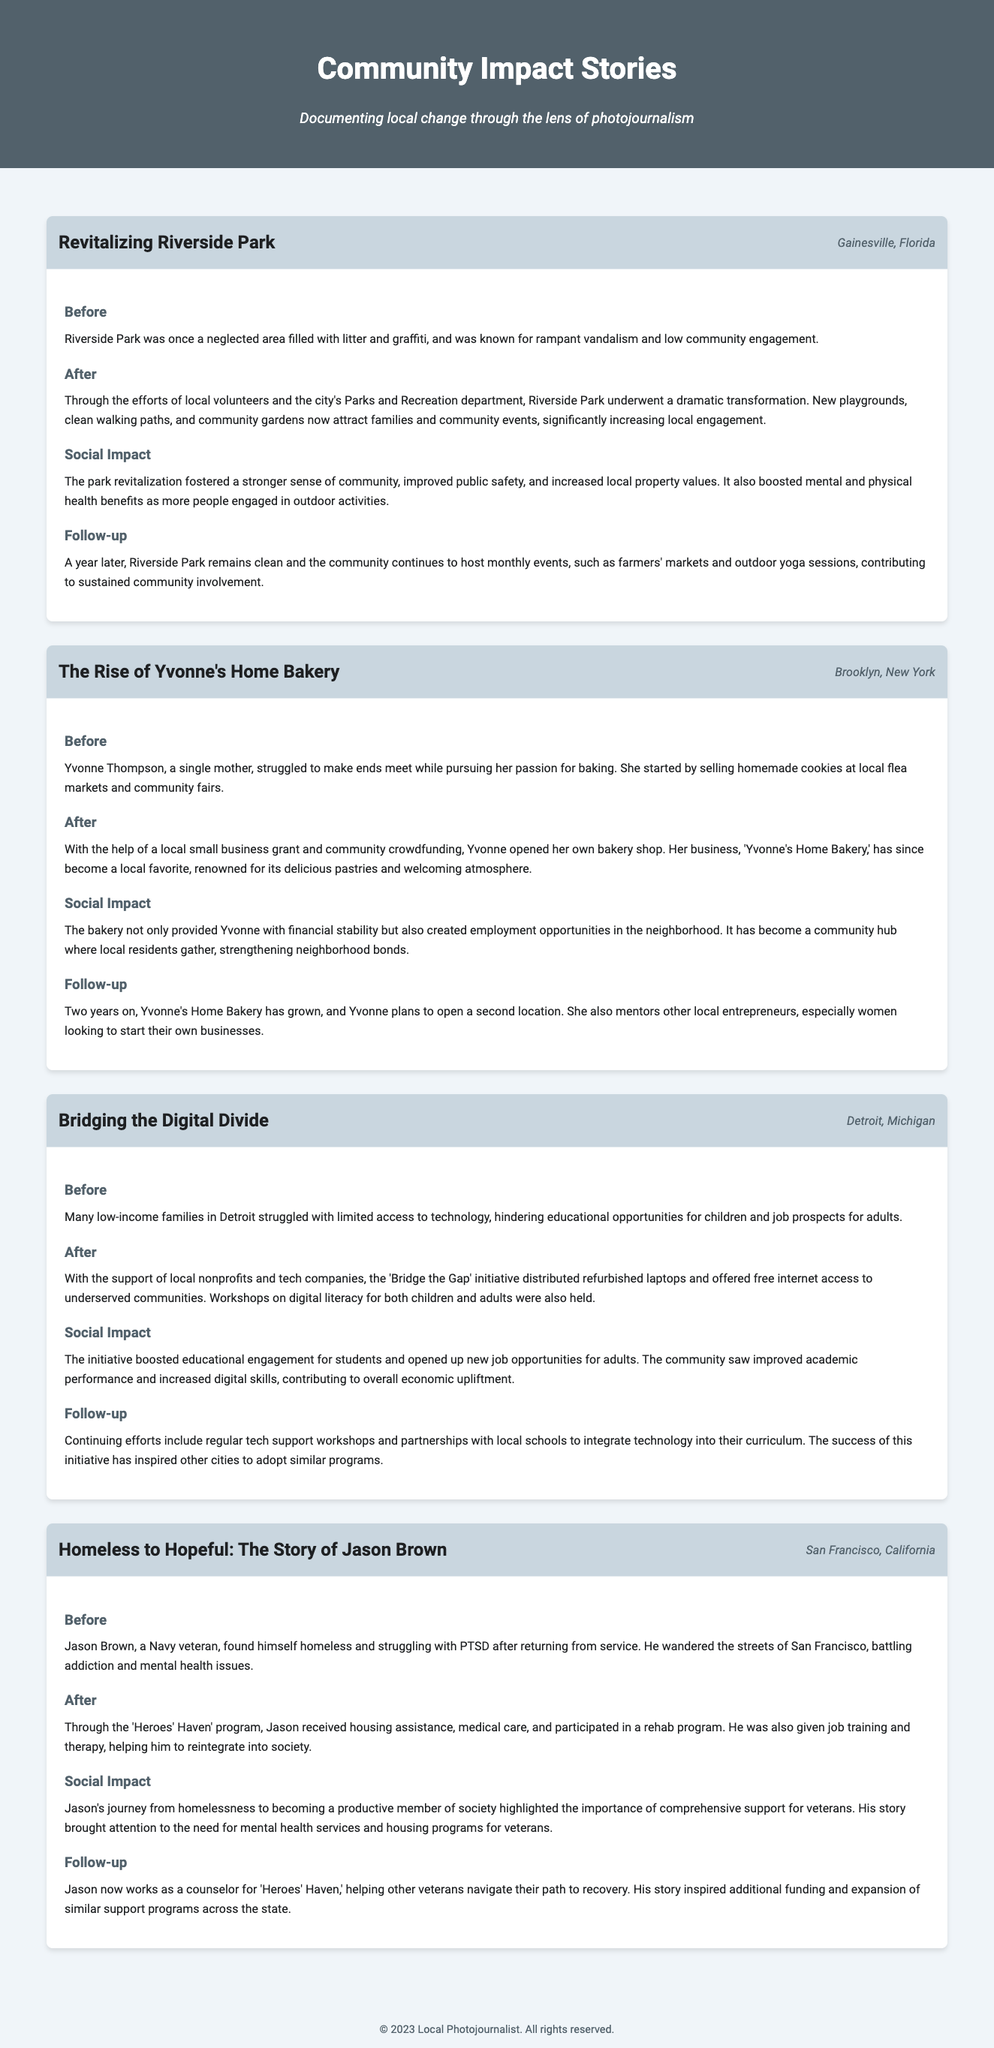What is the title of the first story? The title of the first story is found in the story header, which reads "Revitalizing Riverside Park."
Answer: Revitalizing Riverside Park What city is Yvonne's Home Bakery located in? The location of Yvonne's Home Bakery is mentioned in the story header, which states it is in Brooklyn, New York.
Answer: Brooklyn, New York How many community events are hosted monthly at Riverside Park? The follow-up section describes that monthly events, such as farmers' markets and outdoor yoga sessions, are held at Riverside Park.
Answer: Monthly events What initiative helped distribute refurbished laptops in Detroit? The initiative aimed at distributing refurbished laptops is referred to in the story as "Bridge the Gap."
Answer: Bridge the Gap Which program assisted Jason Brown in his journey from homelessness? The program that provided help to Jason Brown is named "Heroes' Haven."
Answer: Heroes' Haven What type of assistance did Jason receive through the program? The story mentions multiple forms of assistance, including housing assistance, medical care, and job training provided to Jason.
Answer: Housing assistance, medical care, and job training What has Yvonne Thompson planned for her bakery in the future? The follow-up section states that Yvonne plans to open a second location for her bakery.
Answer: Open a second location How did the park revitalization affect local property values? The social impact section notes that the revitalization led to increased local property values.
Answer: Increased local property values 